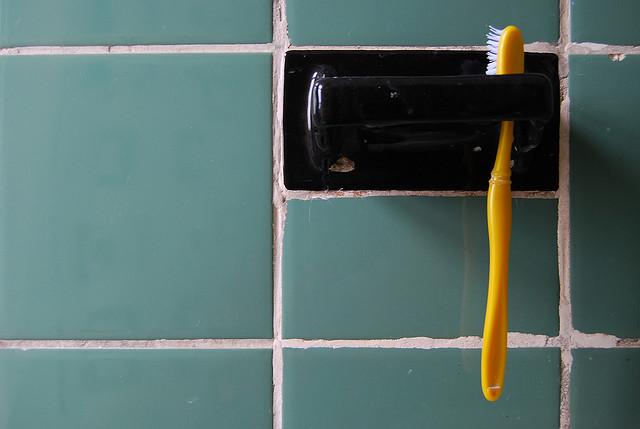At which place in bathroom brush is hang?
Be succinct. Shower. What color is the toothbrush?
Be succinct. Yellow. How many full tiles do you see?
Keep it brief. 2. 